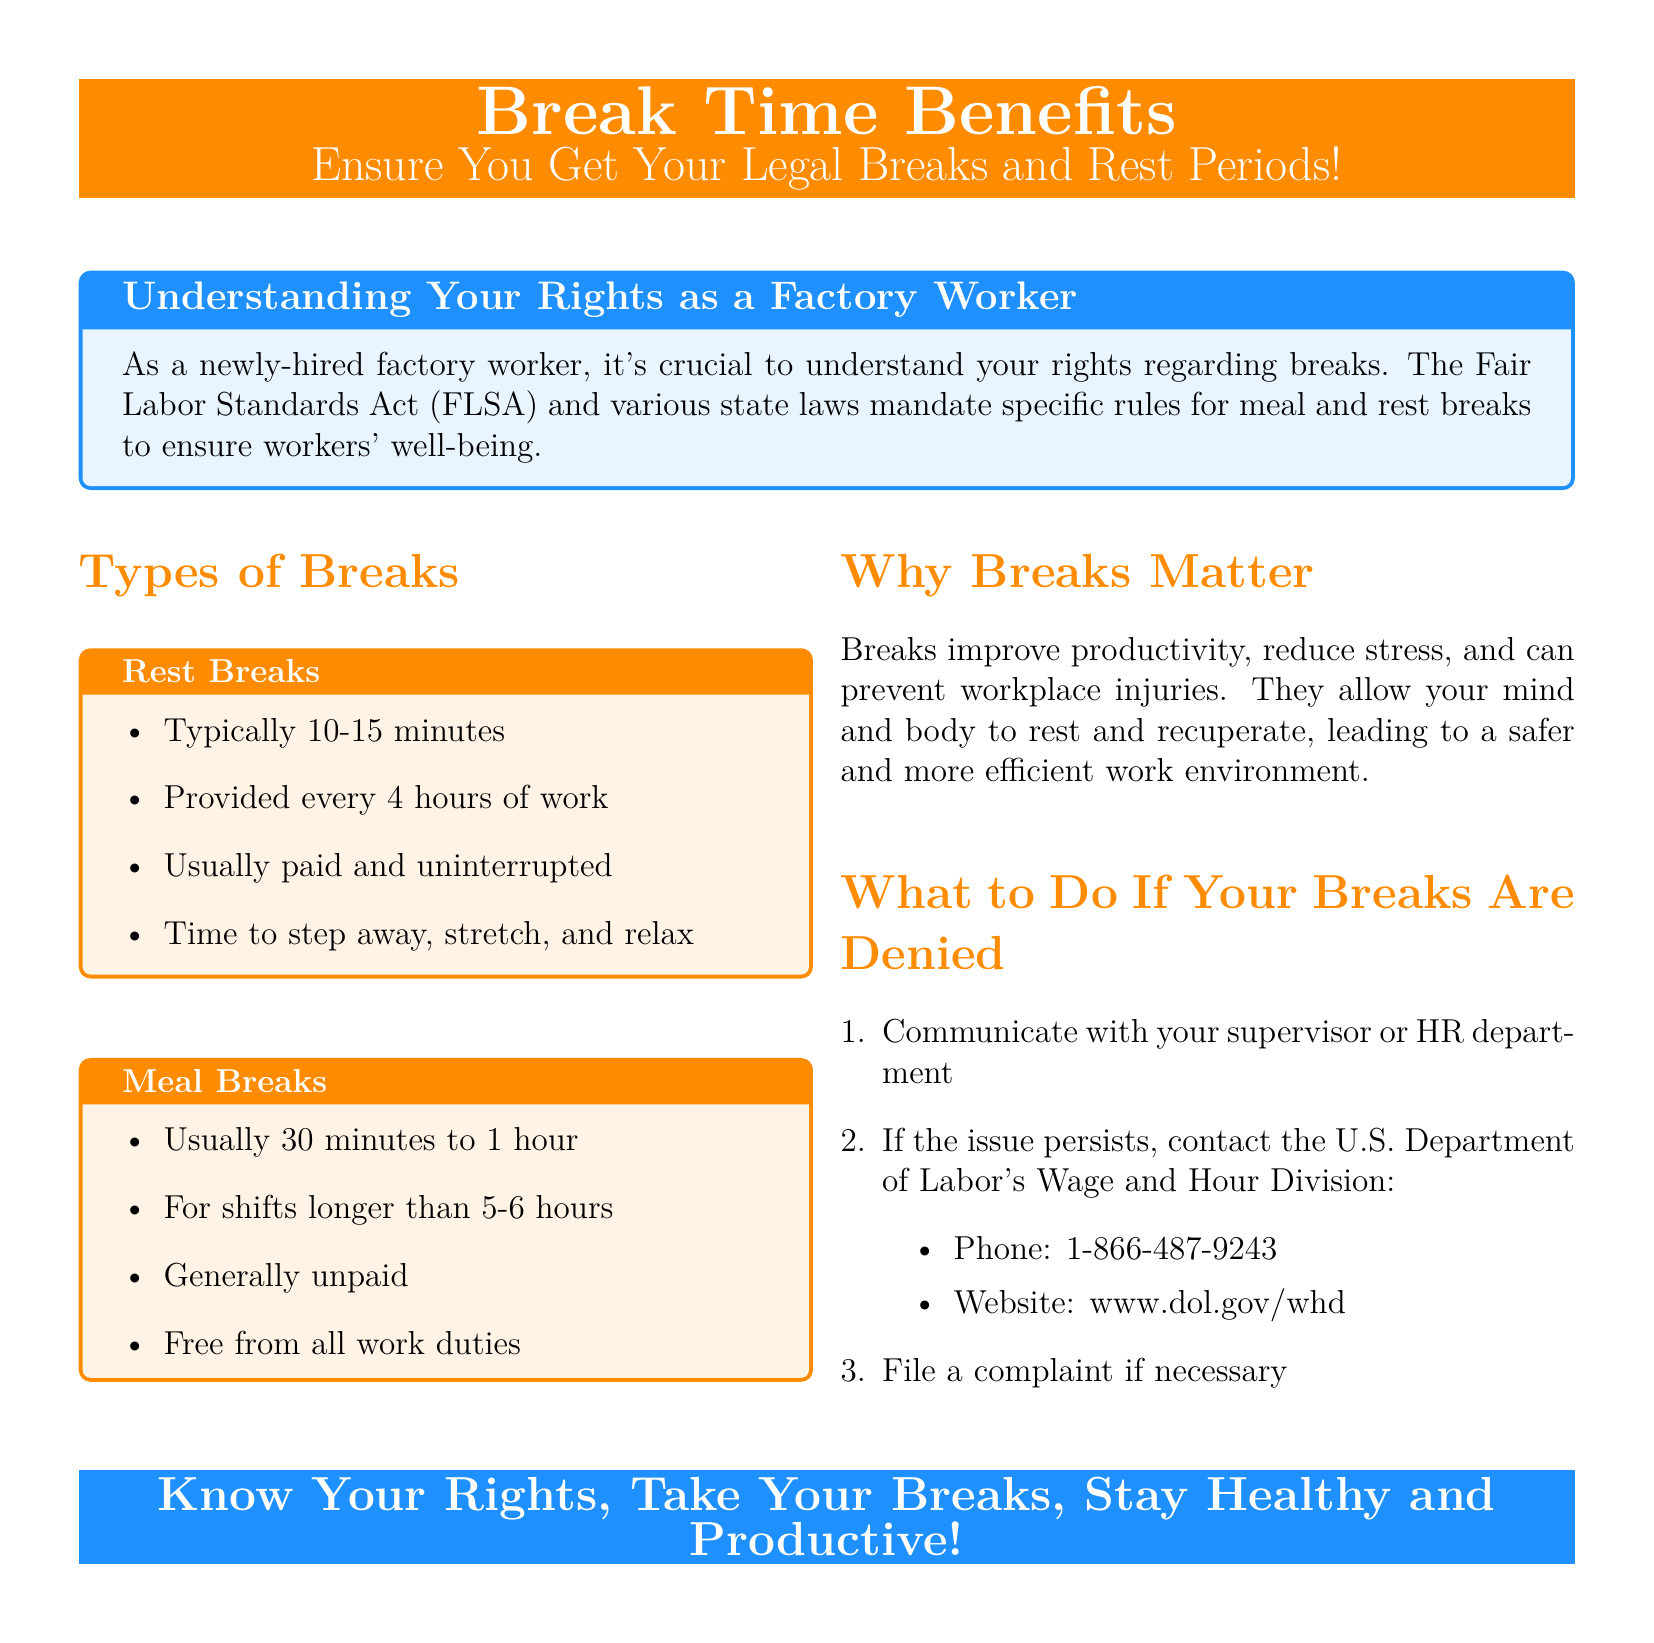what is the title of the advertisement? The title is prominently displayed at the top of the advertisement, highlighting the main theme.
Answer: Break Time Benefits what are the two types of breaks mentioned? The advertisement specifically lists the types of breaks that workers are entitled to, highlighting their importance.
Answer: Rest Breaks, Meal Breaks how long is a typical meal break? The advertisement provides a range for the duration of meal breaks, giving clear guidance.
Answer: 30 minutes to 1 hour how often are rest breaks provided? The advertisement states the frequency of rest breaks, indicating the labor law's requirements for workers.
Answer: Every 4 hours which department can be contacted if breaks are denied? The advertisement lists the proper authority for workers to reach out to if their rights are violated.
Answer: U.S. Department of Labor's Wage and Hour Division what is the recommended action if your breaks are denied? The advertisement emphasizes the importance of communication and action regarding break denials.
Answer: Communicate with your supervisor or HR why are breaks important according to the document? The advertisement mentions the benefits of taking breaks, which is a key point in advocating for workers’ rights.
Answer: Improve productivity, reduce stress, prevent injuries what color is used for the background of the advertisement? The advertisement's color scheme is a significant aspect of its visual appeal.
Answer: White 